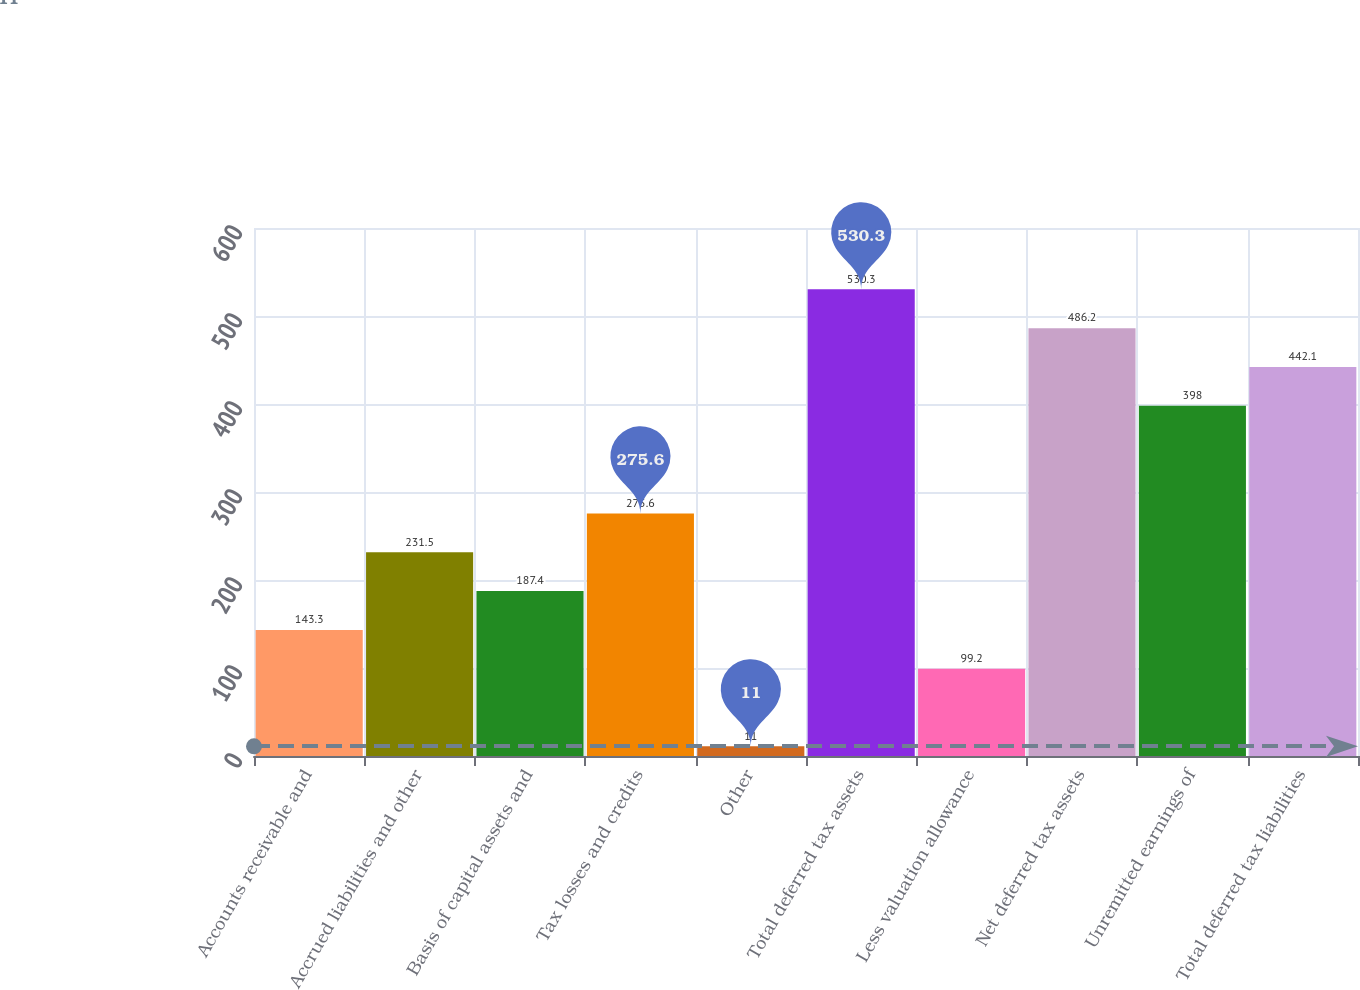Convert chart to OTSL. <chart><loc_0><loc_0><loc_500><loc_500><bar_chart><fcel>Accounts receivable and<fcel>Accrued liabilities and other<fcel>Basis of capital assets and<fcel>Tax losses and credits<fcel>Other<fcel>Total deferred tax assets<fcel>Less valuation allowance<fcel>Net deferred tax assets<fcel>Unremitted earnings of<fcel>Total deferred tax liabilities<nl><fcel>143.3<fcel>231.5<fcel>187.4<fcel>275.6<fcel>11<fcel>530.3<fcel>99.2<fcel>486.2<fcel>398<fcel>442.1<nl></chart> 